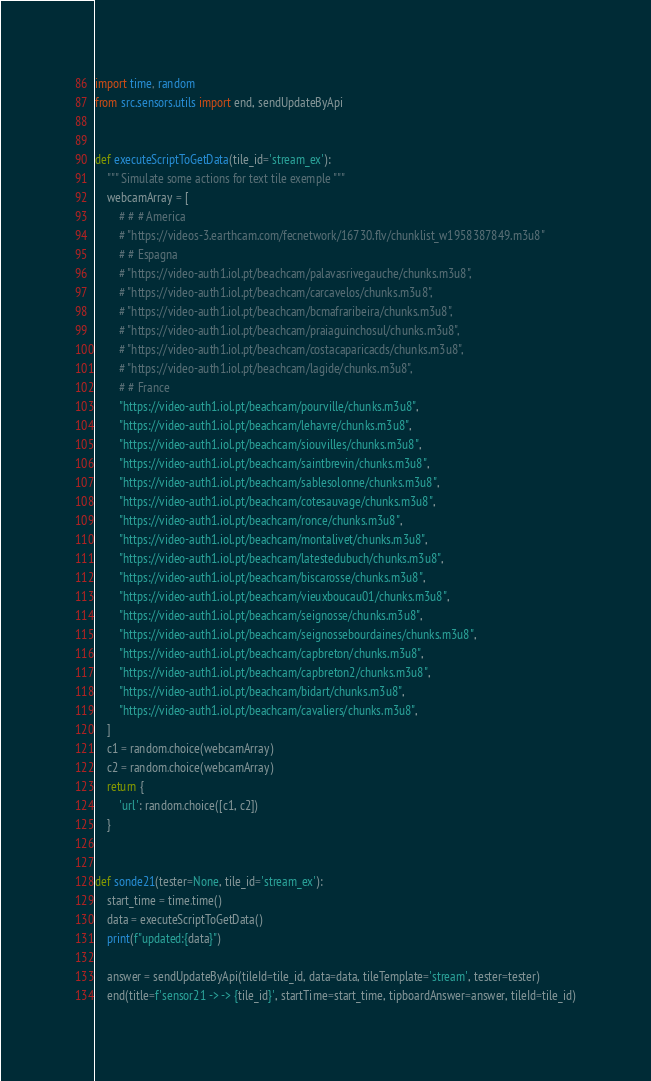<code> <loc_0><loc_0><loc_500><loc_500><_Python_>import time, random
from src.sensors.utils import end, sendUpdateByApi


def executeScriptToGetData(tile_id='stream_ex'):
    """ Simulate some actions for text tile exemple """
    webcamArray = [
        # # # America
        # "https://videos-3.earthcam.com/fecnetwork/16730.flv/chunklist_w1958387849.m3u8"
        # # Espagna
        # "https://video-auth1.iol.pt/beachcam/palavasrivegauche/chunks.m3u8",
        # "https://video-auth1.iol.pt/beachcam/carcavelos/chunks.m3u8",
        # "https://video-auth1.iol.pt/beachcam/bcmafraribeira/chunks.m3u8",
        # "https://video-auth1.iol.pt/beachcam/praiaguinchosul/chunks.m3u8",
        # "https://video-auth1.iol.pt/beachcam/costacaparicacds/chunks.m3u8",
        # "https://video-auth1.iol.pt/beachcam/lagide/chunks.m3u8",
        # # France
        "https://video-auth1.iol.pt/beachcam/pourville/chunks.m3u8",
        "https://video-auth1.iol.pt/beachcam/lehavre/chunks.m3u8",
        "https://video-auth1.iol.pt/beachcam/siouvilles/chunks.m3u8",
        "https://video-auth1.iol.pt/beachcam/saintbrevin/chunks.m3u8",
        "https://video-auth1.iol.pt/beachcam/sablesolonne/chunks.m3u8",
        "https://video-auth1.iol.pt/beachcam/cotesauvage/chunks.m3u8",
        "https://video-auth1.iol.pt/beachcam/ronce/chunks.m3u8",
        "https://video-auth1.iol.pt/beachcam/montalivet/chunks.m3u8",
        "https://video-auth1.iol.pt/beachcam/latestedubuch/chunks.m3u8",
        "https://video-auth1.iol.pt/beachcam/biscarosse/chunks.m3u8",
        "https://video-auth1.iol.pt/beachcam/vieuxboucau01/chunks.m3u8",
        "https://video-auth1.iol.pt/beachcam/seignosse/chunks.m3u8",
        "https://video-auth1.iol.pt/beachcam/seignossebourdaines/chunks.m3u8",
        "https://video-auth1.iol.pt/beachcam/capbreton/chunks.m3u8",
        "https://video-auth1.iol.pt/beachcam/capbreton2/chunks.m3u8",
        "https://video-auth1.iol.pt/beachcam/bidart/chunks.m3u8",
        "https://video-auth1.iol.pt/beachcam/cavaliers/chunks.m3u8",
    ]
    c1 = random.choice(webcamArray)
    c2 = random.choice(webcamArray)
    return {
        'url': random.choice([c1, c2])
    }


def sonde21(tester=None, tile_id='stream_ex'):
    start_time = time.time()
    data = executeScriptToGetData()
    print(f"updated:{data}")

    answer = sendUpdateByApi(tileId=tile_id, data=data, tileTemplate='stream', tester=tester)
    end(title=f'sensor21 -> -> {tile_id}', startTime=start_time, tipboardAnswer=answer, tileId=tile_id)
</code> 